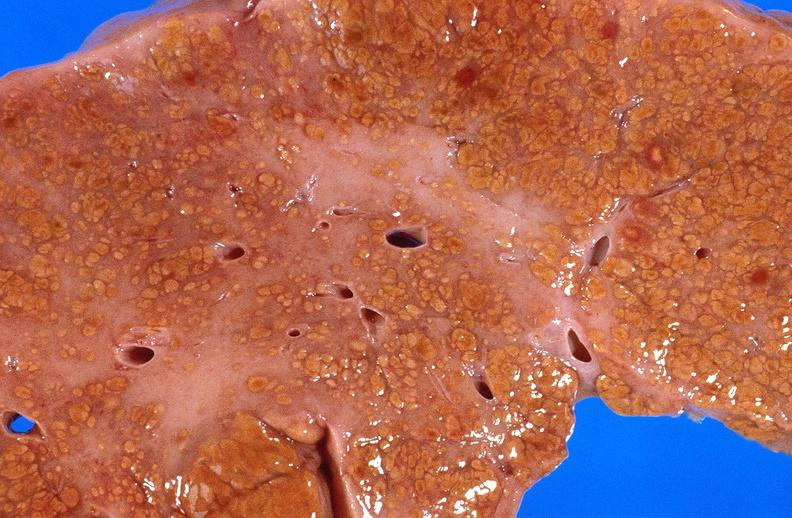s liver present?
Answer the question using a single word or phrase. Yes 